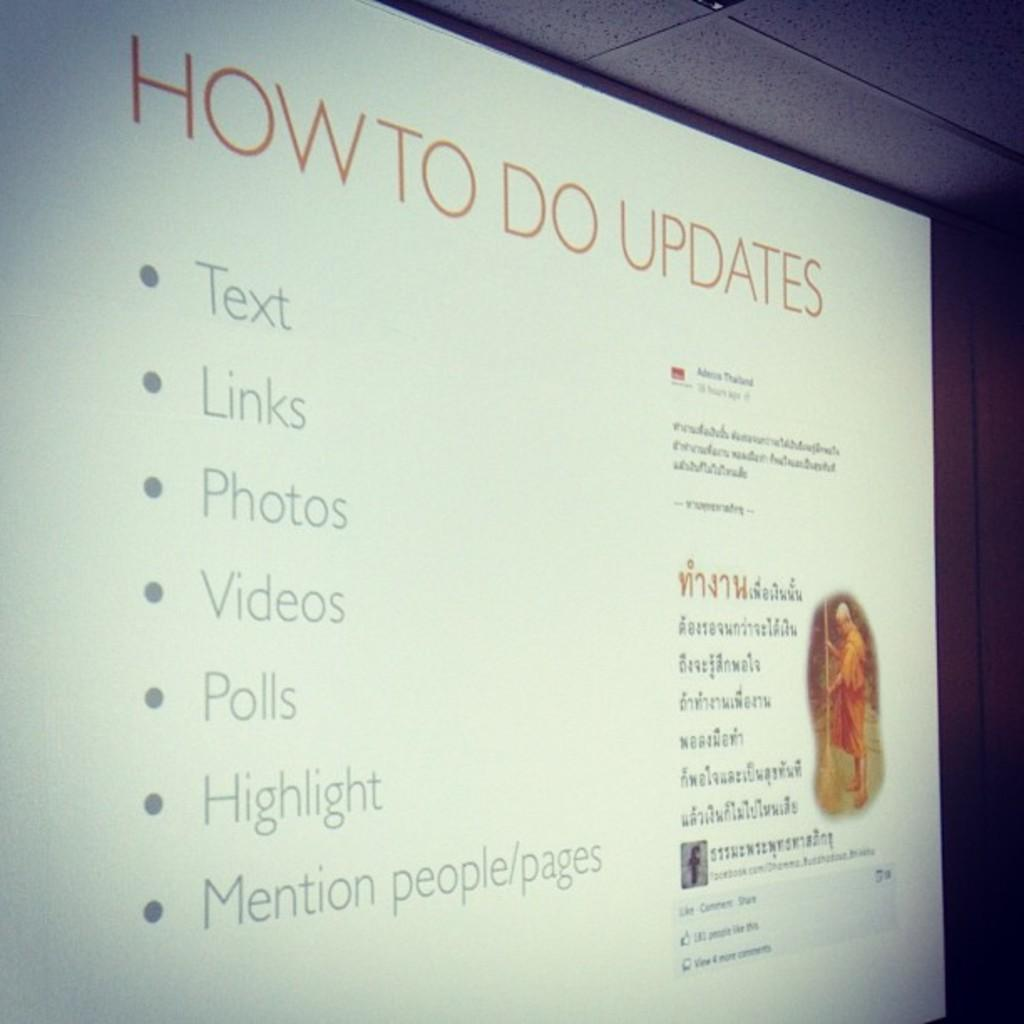Provide a one-sentence caption for the provided image. A computer screen showing text, how to do updates with lists of things to do. 